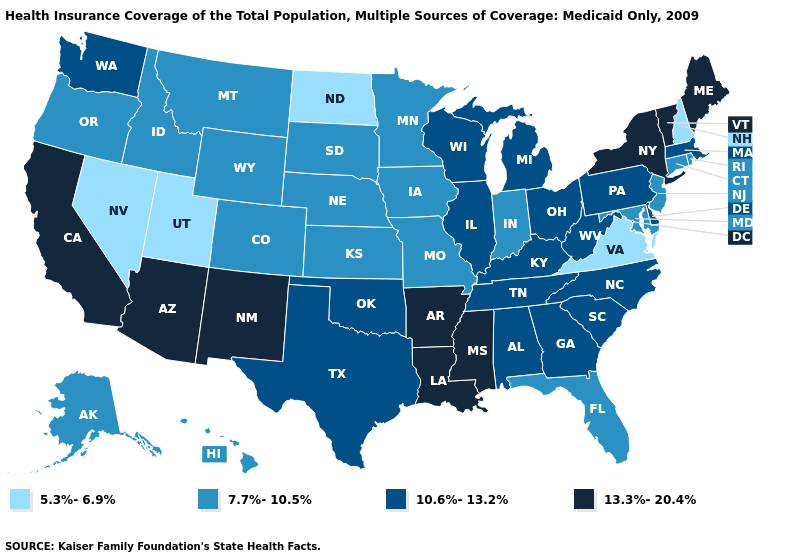Among the states that border New Hampshire , which have the highest value?
Write a very short answer. Maine, Vermont. What is the value of Montana?
Concise answer only. 7.7%-10.5%. Among the states that border North Dakota , which have the lowest value?
Answer briefly. Minnesota, Montana, South Dakota. What is the value of Nebraska?
Short answer required. 7.7%-10.5%. What is the value of Arizona?
Keep it brief. 13.3%-20.4%. Among the states that border Pennsylvania , which have the highest value?
Answer briefly. New York. Name the states that have a value in the range 7.7%-10.5%?
Be succinct. Alaska, Colorado, Connecticut, Florida, Hawaii, Idaho, Indiana, Iowa, Kansas, Maryland, Minnesota, Missouri, Montana, Nebraska, New Jersey, Oregon, Rhode Island, South Dakota, Wyoming. What is the highest value in states that border Wyoming?
Quick response, please. 7.7%-10.5%. What is the value of Idaho?
Concise answer only. 7.7%-10.5%. Among the states that border Minnesota , does South Dakota have the highest value?
Keep it brief. No. What is the highest value in the South ?
Keep it brief. 13.3%-20.4%. Among the states that border Maryland , which have the highest value?
Concise answer only. Delaware, Pennsylvania, West Virginia. What is the highest value in the South ?
Answer briefly. 13.3%-20.4%. Name the states that have a value in the range 10.6%-13.2%?
Answer briefly. Alabama, Delaware, Georgia, Illinois, Kentucky, Massachusetts, Michigan, North Carolina, Ohio, Oklahoma, Pennsylvania, South Carolina, Tennessee, Texas, Washington, West Virginia, Wisconsin. Name the states that have a value in the range 7.7%-10.5%?
Write a very short answer. Alaska, Colorado, Connecticut, Florida, Hawaii, Idaho, Indiana, Iowa, Kansas, Maryland, Minnesota, Missouri, Montana, Nebraska, New Jersey, Oregon, Rhode Island, South Dakota, Wyoming. 